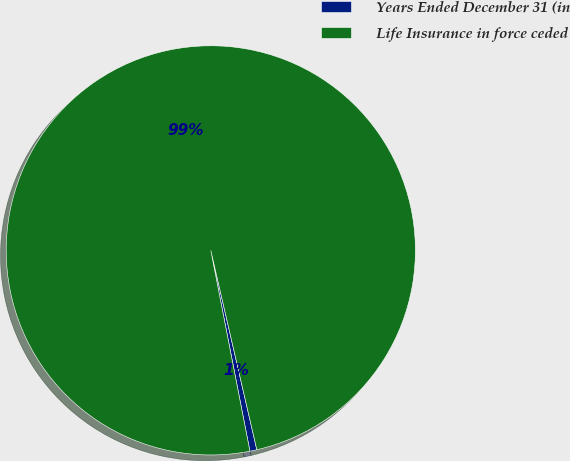<chart> <loc_0><loc_0><loc_500><loc_500><pie_chart><fcel>Years Ended December 31 (in<fcel>Life Insurance in force ceded<nl><fcel>0.55%<fcel>99.45%<nl></chart> 